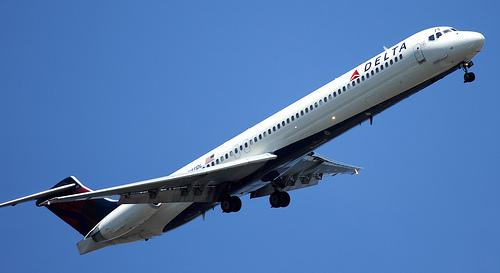Question: what is flying?
Choices:
A. A plane.
B. A helicopter.
C. A hang glider.
D. A hot air balloon.
Answer with the letter. Answer: A Question: what is mostly white?
Choices:
A. A cloud.
B. Airplane.
C. A helicopter.
D. A hot air balloon.
Answer with the letter. Answer: B Question: where are windows?
Choices:
A. On the left.
B. On side of plane.
C. On the right.
D. In the center.
Answer with the letter. Answer: B Question: why does the plane have wings?
Choices:
A. Aerodynamics.
B. Hold the engines.
C. Cover fuel lines for engines.
D. To fly.
Answer with the letter. Answer: D Question: what is navy blue?
Choices:
A. Nose.
B. Plane's tail.
C. Wings.
D. Fuselage.
Answer with the letter. Answer: B Question: where was the picture taken?
Choices:
A. Under car.
B. Under truck.
C. Under ground.
D. Under plane.
Answer with the letter. Answer: D 